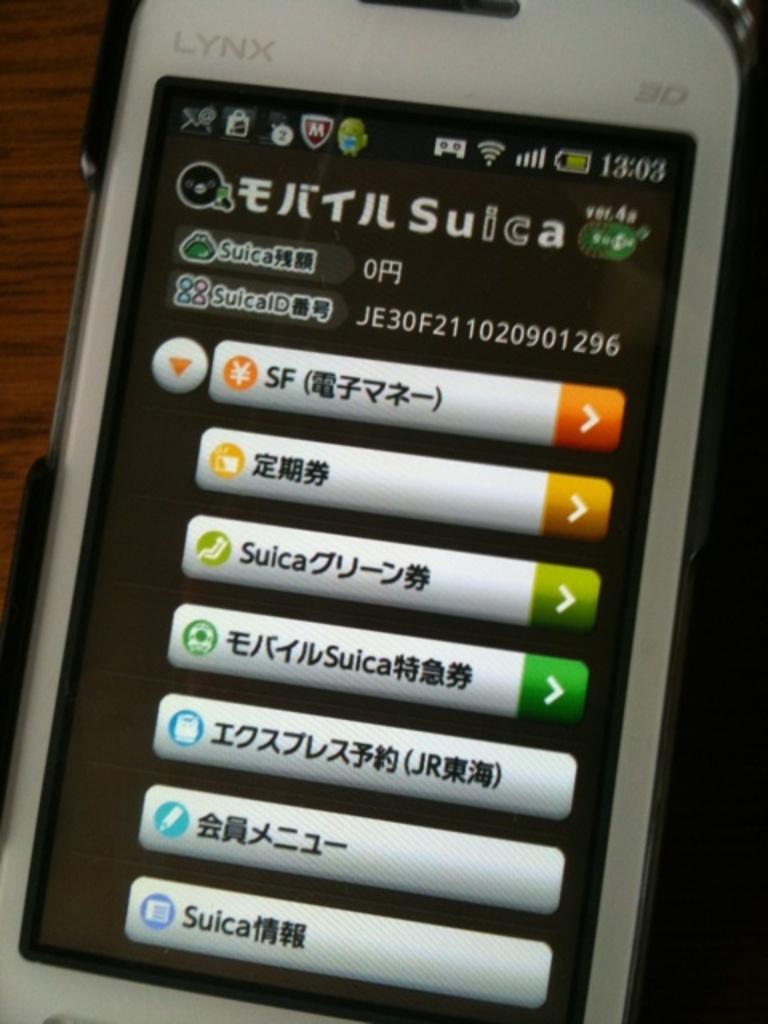What does the phone sceen read?
Your answer should be compact. Unanswerable. What brand of phone is seen?
Your answer should be very brief. Lynx. 